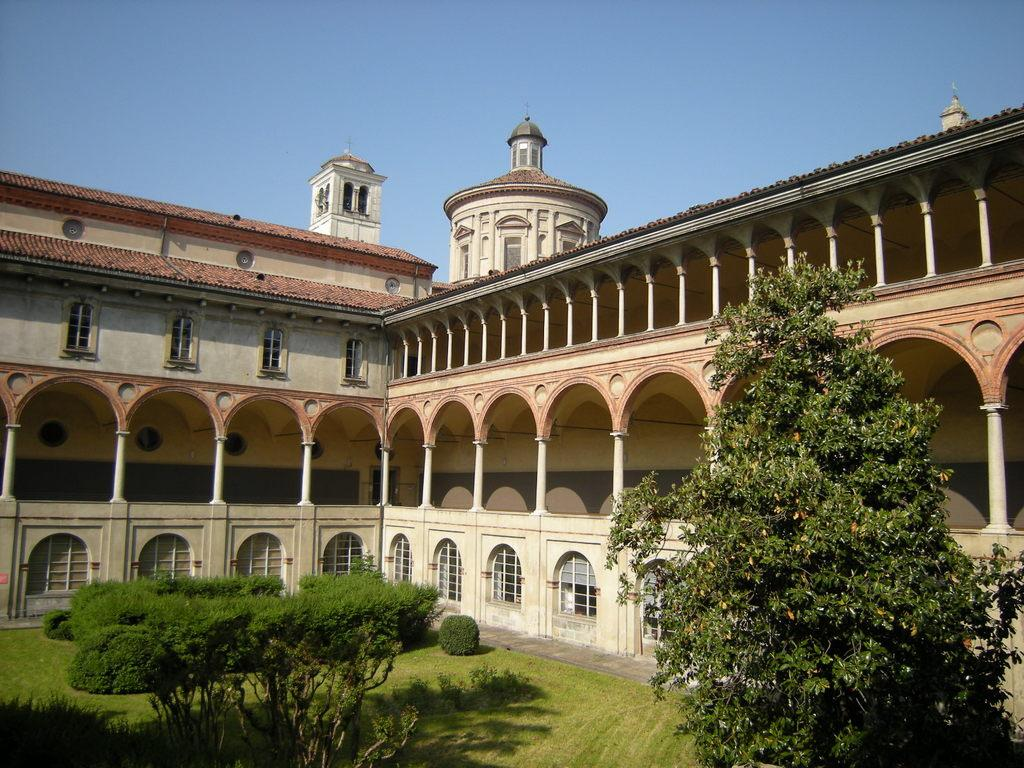What type of vegetation is present in the image? There is grass and multiple plants in the image. What is located at the front of the image? There is a tree in the front of the image. What can be seen in the background of the image? There is a building and the sky visible in the background of the image. What type of furniture is visible in the image? There is no furniture present in the image. What kind of operation is being performed on the tree in the image? There is no operation being performed on the tree in the image; it is simply standing in the front of the image. 